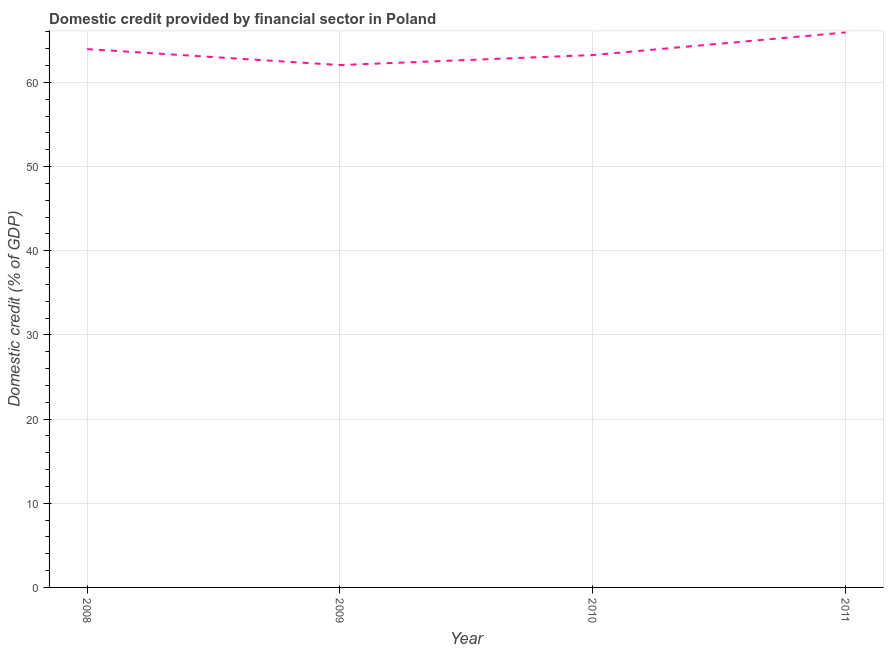What is the domestic credit provided by financial sector in 2010?
Your answer should be very brief. 63.24. Across all years, what is the maximum domestic credit provided by financial sector?
Provide a short and direct response. 65.92. Across all years, what is the minimum domestic credit provided by financial sector?
Offer a terse response. 62.05. What is the sum of the domestic credit provided by financial sector?
Your answer should be very brief. 255.16. What is the difference between the domestic credit provided by financial sector in 2009 and 2011?
Keep it short and to the point. -3.87. What is the average domestic credit provided by financial sector per year?
Ensure brevity in your answer.  63.79. What is the median domestic credit provided by financial sector?
Your answer should be very brief. 63.59. Do a majority of the years between 2010 and 2009 (inclusive) have domestic credit provided by financial sector greater than 42 %?
Provide a short and direct response. No. What is the ratio of the domestic credit provided by financial sector in 2008 to that in 2010?
Your response must be concise. 1.01. Is the domestic credit provided by financial sector in 2009 less than that in 2010?
Offer a terse response. Yes. What is the difference between the highest and the second highest domestic credit provided by financial sector?
Keep it short and to the point. 1.98. Is the sum of the domestic credit provided by financial sector in 2008 and 2011 greater than the maximum domestic credit provided by financial sector across all years?
Give a very brief answer. Yes. What is the difference between the highest and the lowest domestic credit provided by financial sector?
Offer a very short reply. 3.87. In how many years, is the domestic credit provided by financial sector greater than the average domestic credit provided by financial sector taken over all years?
Offer a very short reply. 2. Does the domestic credit provided by financial sector monotonically increase over the years?
Offer a terse response. No. How many lines are there?
Your answer should be very brief. 1. Does the graph contain any zero values?
Provide a short and direct response. No. Does the graph contain grids?
Ensure brevity in your answer.  Yes. What is the title of the graph?
Your answer should be very brief. Domestic credit provided by financial sector in Poland. What is the label or title of the X-axis?
Ensure brevity in your answer.  Year. What is the label or title of the Y-axis?
Provide a short and direct response. Domestic credit (% of GDP). What is the Domestic credit (% of GDP) in 2008?
Keep it short and to the point. 63.95. What is the Domestic credit (% of GDP) of 2009?
Ensure brevity in your answer.  62.05. What is the Domestic credit (% of GDP) of 2010?
Offer a very short reply. 63.24. What is the Domestic credit (% of GDP) of 2011?
Ensure brevity in your answer.  65.92. What is the difference between the Domestic credit (% of GDP) in 2008 and 2009?
Keep it short and to the point. 1.89. What is the difference between the Domestic credit (% of GDP) in 2008 and 2010?
Provide a succinct answer. 0.7. What is the difference between the Domestic credit (% of GDP) in 2008 and 2011?
Your answer should be compact. -1.98. What is the difference between the Domestic credit (% of GDP) in 2009 and 2010?
Your answer should be very brief. -1.19. What is the difference between the Domestic credit (% of GDP) in 2009 and 2011?
Make the answer very short. -3.87. What is the difference between the Domestic credit (% of GDP) in 2010 and 2011?
Offer a very short reply. -2.68. What is the ratio of the Domestic credit (% of GDP) in 2008 to that in 2009?
Your answer should be compact. 1.03. What is the ratio of the Domestic credit (% of GDP) in 2008 to that in 2010?
Keep it short and to the point. 1.01. What is the ratio of the Domestic credit (% of GDP) in 2008 to that in 2011?
Your response must be concise. 0.97. What is the ratio of the Domestic credit (% of GDP) in 2009 to that in 2011?
Offer a very short reply. 0.94. What is the ratio of the Domestic credit (% of GDP) in 2010 to that in 2011?
Provide a short and direct response. 0.96. 